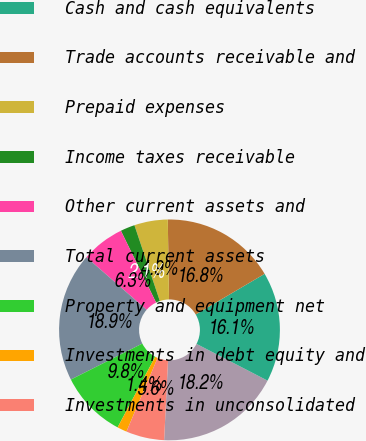<chart> <loc_0><loc_0><loc_500><loc_500><pie_chart><fcel>(in millions except per share<fcel>Cash and cash equivalents<fcel>Trade accounts receivable and<fcel>Prepaid expenses<fcel>Income taxes receivable<fcel>Other current assets and<fcel>Total current assets<fcel>Property and equipment net<fcel>Investments in debt equity and<fcel>Investments in unconsolidated<nl><fcel>18.17%<fcel>16.07%<fcel>16.77%<fcel>4.9%<fcel>2.11%<fcel>6.3%<fcel>18.87%<fcel>9.79%<fcel>1.41%<fcel>5.6%<nl></chart> 